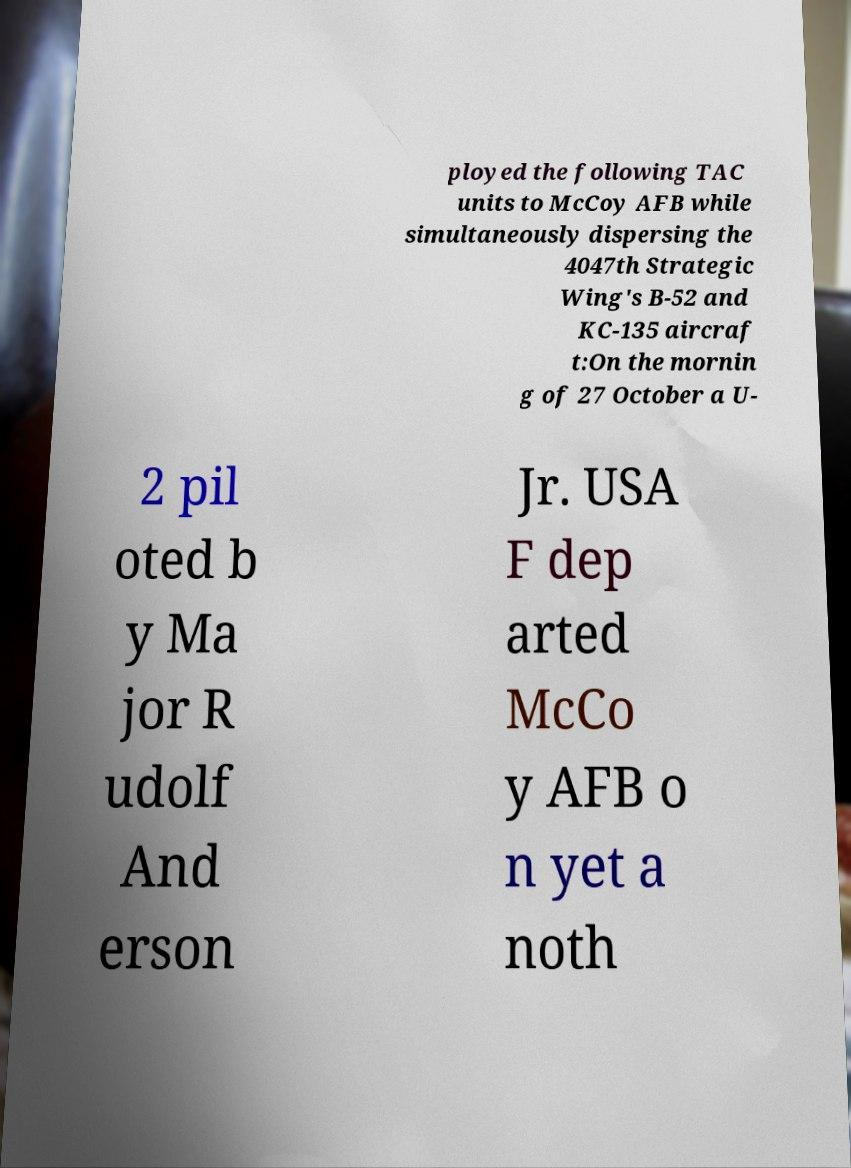I need the written content from this picture converted into text. Can you do that? ployed the following TAC units to McCoy AFB while simultaneously dispersing the 4047th Strategic Wing's B-52 and KC-135 aircraf t:On the mornin g of 27 October a U- 2 pil oted b y Ma jor R udolf And erson Jr. USA F dep arted McCo y AFB o n yet a noth 